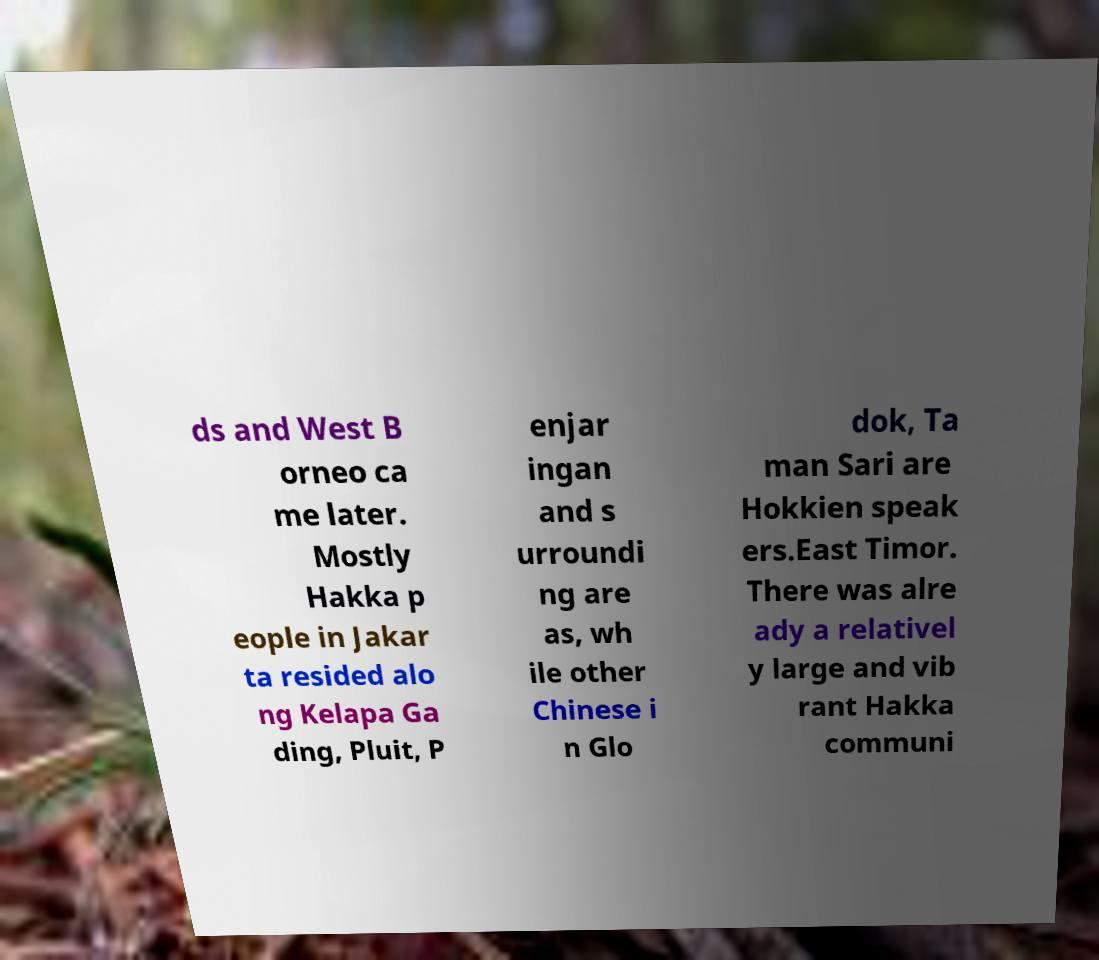Please identify and transcribe the text found in this image. ds and West B orneo ca me later. Mostly Hakka p eople in Jakar ta resided alo ng Kelapa Ga ding, Pluit, P enjar ingan and s urroundi ng are as, wh ile other Chinese i n Glo dok, Ta man Sari are Hokkien speak ers.East Timor. There was alre ady a relativel y large and vib rant Hakka communi 